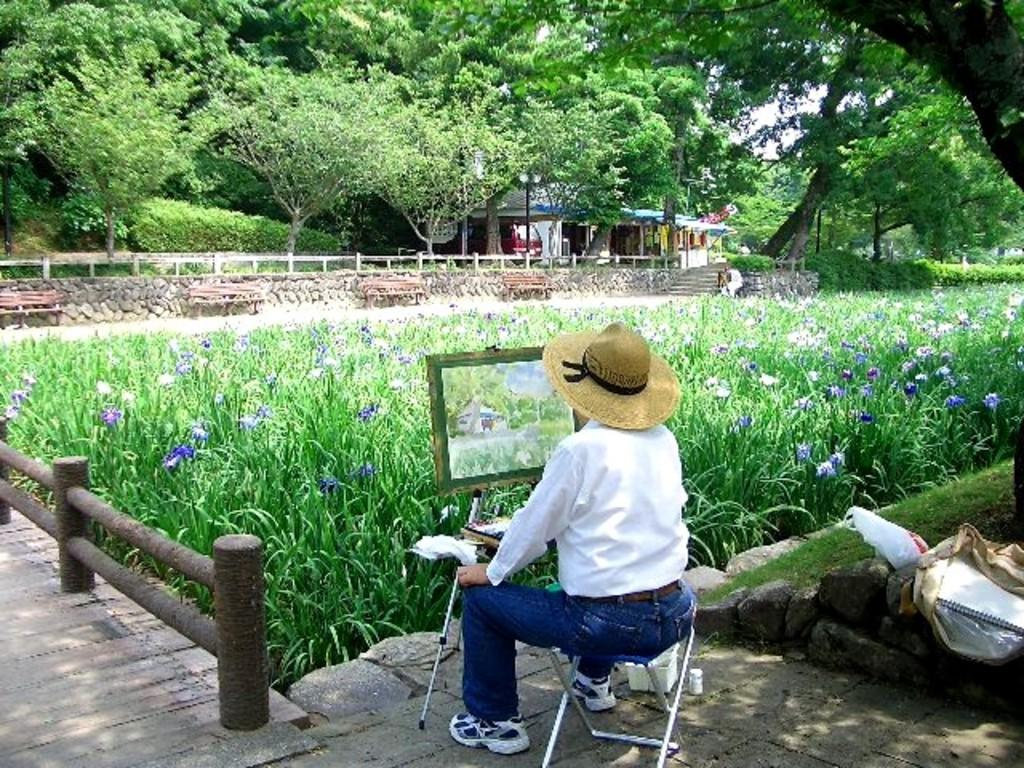What is the person in the image doing? The person is sitting on a chair in the image. What type of artwork is present in the image? The image contains a painting. What type of vegetation can be seen in the image? There are plants and trees in the image. What type of seating is available in the image? There are benches in the image. What type of barrier is present in the image? There is a fence in the image. What type of structure is visible in the image? There is a house in the image. What part of the natural environment is visible in the image? The sky is visible in the image. What type of corn is growing in the image? There is no corn present in the image. What channel is the person watching on the television in the image? There is no television present in the image. 